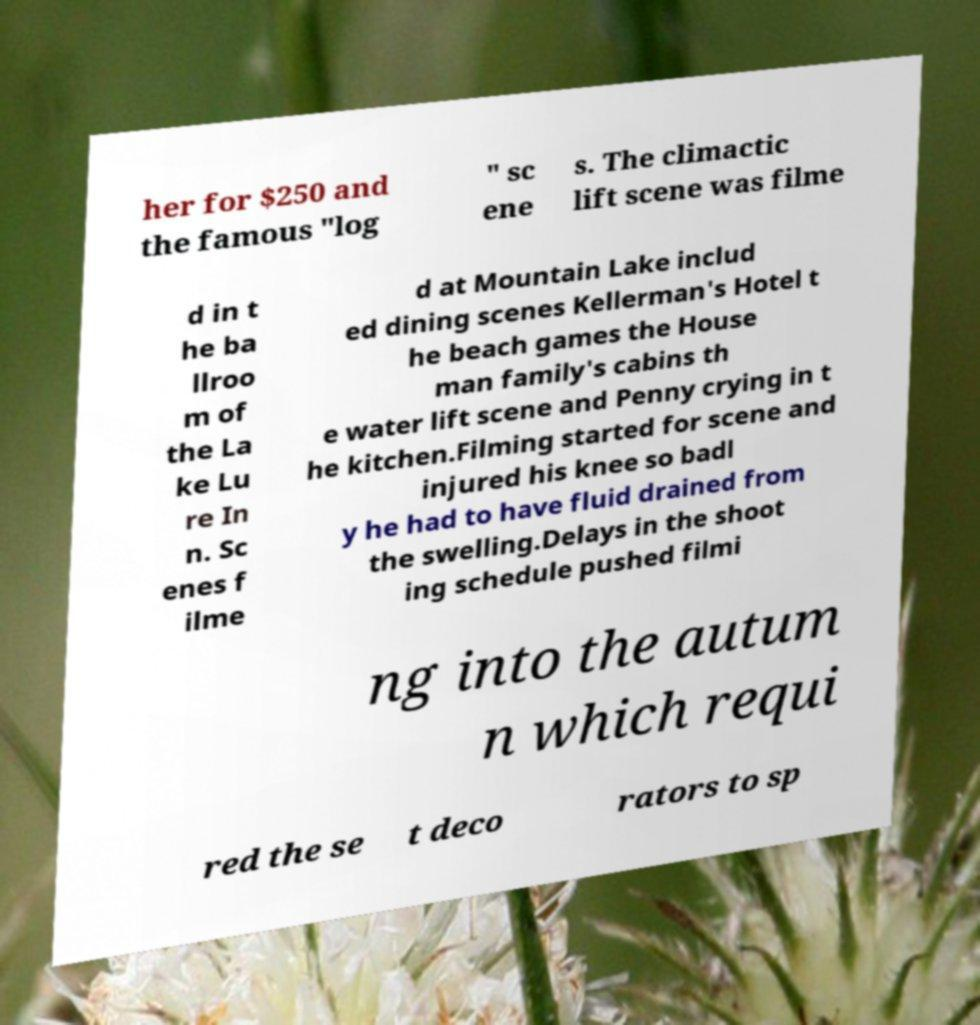Can you read and provide the text displayed in the image?This photo seems to have some interesting text. Can you extract and type it out for me? her for $250 and the famous "log " sc ene s. The climactic lift scene was filme d in t he ba llroo m of the La ke Lu re In n. Sc enes f ilme d at Mountain Lake includ ed dining scenes Kellerman's Hotel t he beach games the House man family's cabins th e water lift scene and Penny crying in t he kitchen.Filming started for scene and injured his knee so badl y he had to have fluid drained from the swelling.Delays in the shoot ing schedule pushed filmi ng into the autum n which requi red the se t deco rators to sp 